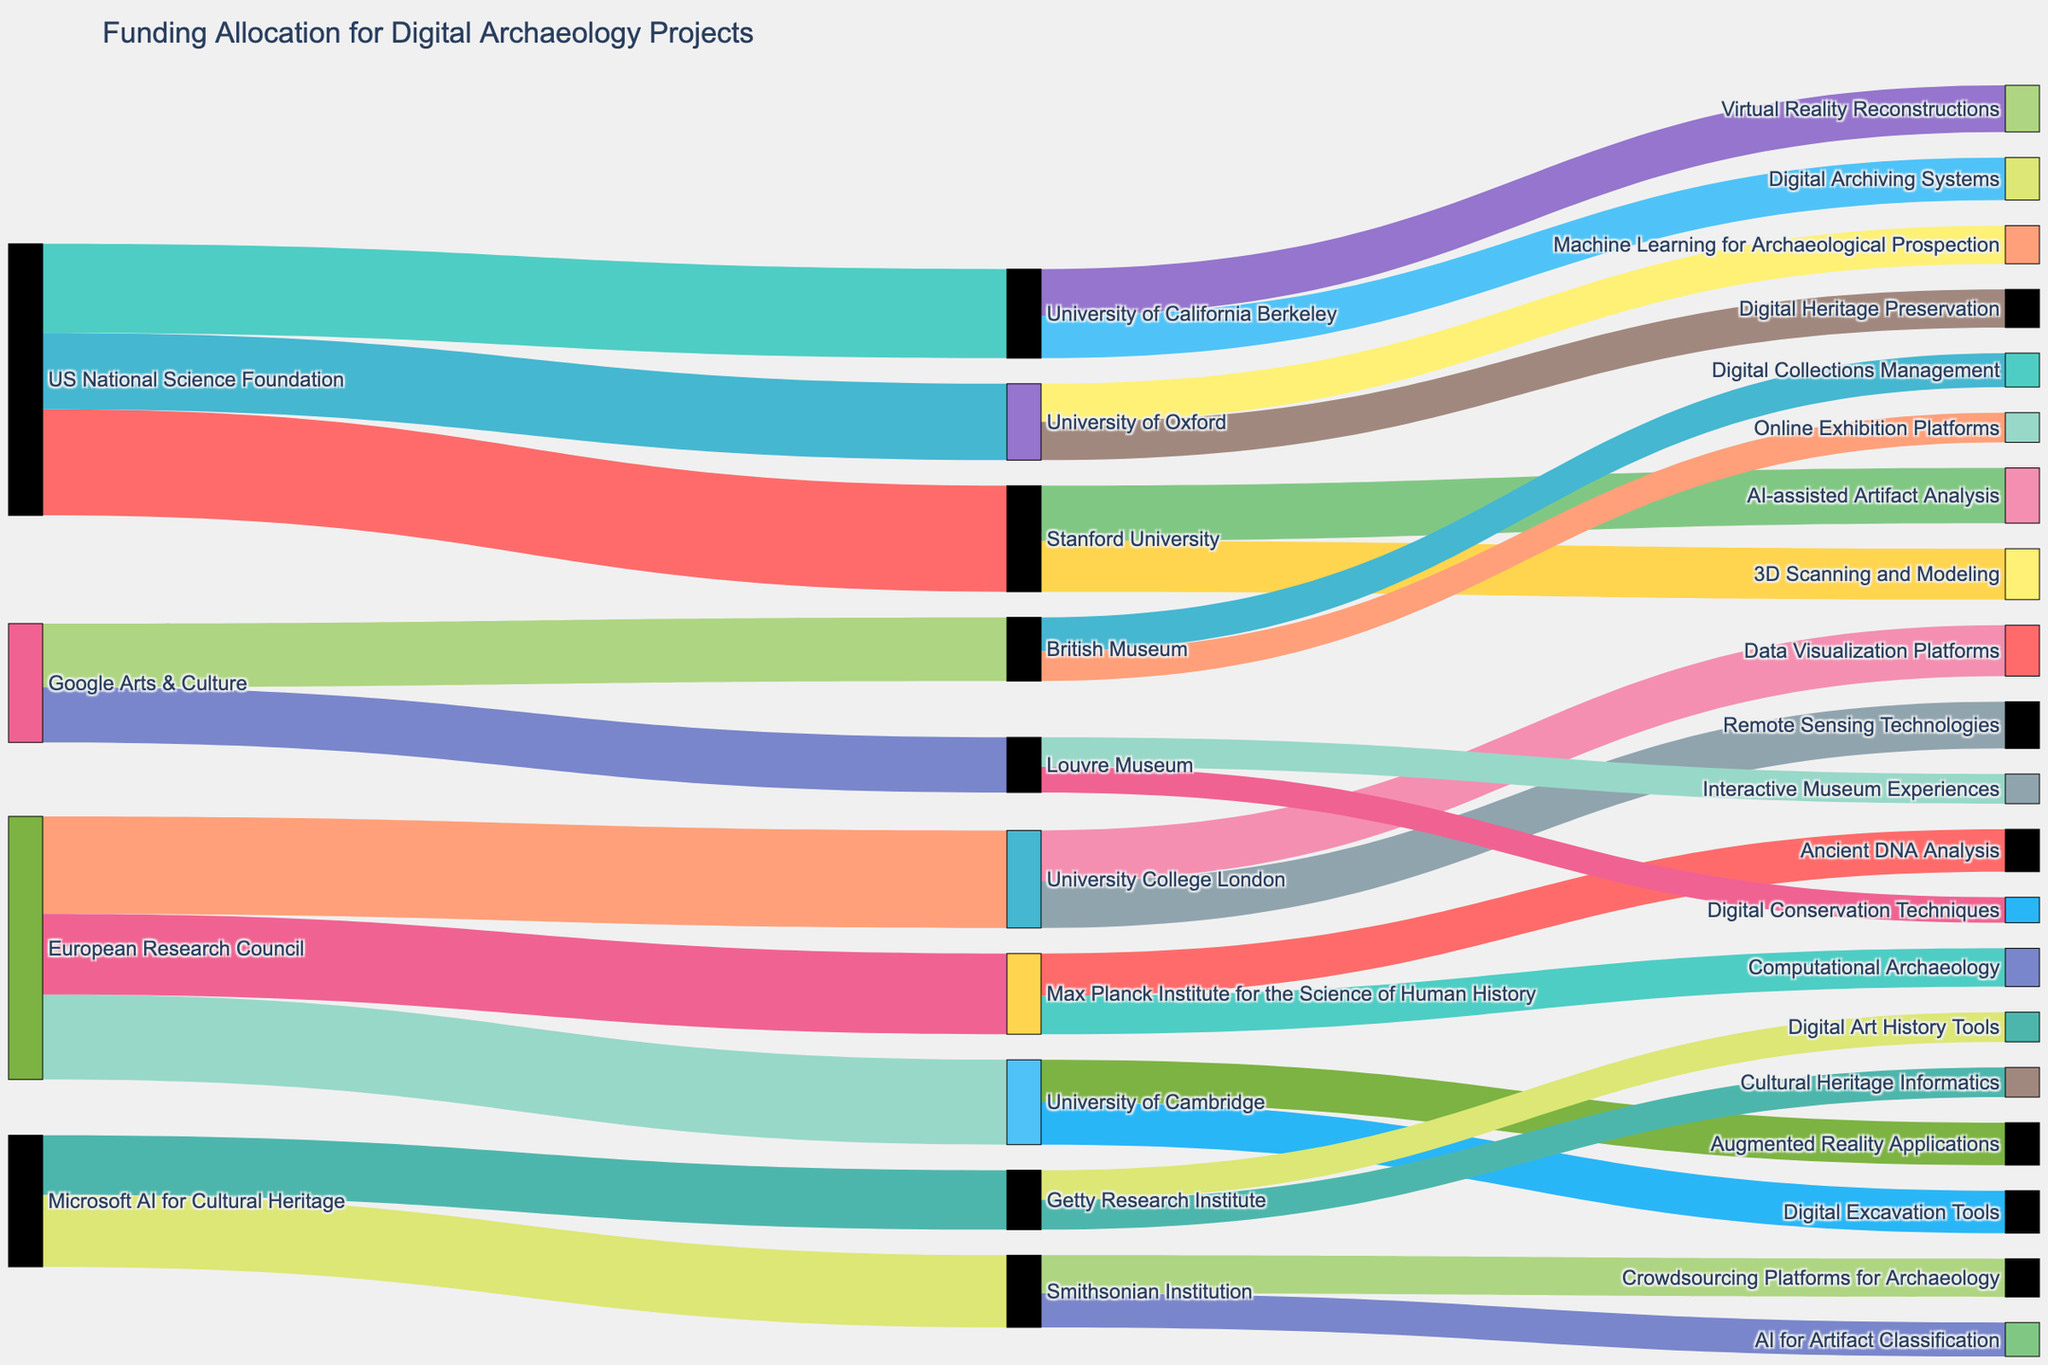What is the title of the Sankey Diagram? The title is typically found at the top of the diagram and indicates the main subject. By looking at the top of the figure, we can see the heading.
Answer: Funding Allocation for Digital Archaeology Projects How many sources are funding digital archaeology projects? To determine how many organizations are providing funds, count the distinct entities on the left side of the diagram that have outgoing flows.
Answer: 4 Which institution received the highest funding from a single source, and how much did they get? By examining the thickness of the links from each funding source to the institutions and reading the labels, we identify the maximum value.
Answer: Stanford University, $2,500,000 How much total funding did the US National Science Foundation allocate? Add the values associated with all the links originating from the US National Science Foundation to get the total allocation. There are three funding paths: Stanford University ($2,500,000), University of California Berkeley ($2,100,000), and University of Oxford ($1,800,000).
Answer: $6,400,000 Which project received the least funding, and from which institution? Look at the thickness and labels of the links connecting institutions to their respective projects, and identify the smallest value.
Answer: Digital Conservation Techniques, Louvre Museum How does the funding to the University of Cambridge compare to that of the Max Planck Institute for the Science of Human History? Sum the funding values directed to each institution from their sources, then compare these totals. University of Cambridge receives $2,000,000 (all from European Research Council), while Max Planck Institute for the Science of Human History receives $1,900,000 (also from European Research Council).
Answer: University of Cambridge receives more What percentage of Google Arts & Culture funding goes to British Museum? Calculate the proportion of funding Google Arts & Culture gives to British Museum vis-a-vis the total from Google Arts & Culture. British Museum ($1,500,000) and Louvre Museum ($1,300,000) sum to $2,800,000.
Answer: Approximately 53.6% What is the combined funding for AI-related projects across all institutions? Identify and sum the values of all projects related to AI, such as AI-assisted Artifact Analysis ($1,300,000), AI for Artifact Classification ($800,000), and others as identified from project names.
Answer: $2,100,000 (Stanford and Smithsonian) Which country hosts the most institutions receiving funding, based on the diagram? Count the target institutions grouped by country: US (Stanford, UC Berkeley, Smithsonian, Getty), UK (Oxford, UCL, Cambridge, British Museum), Germany (Max Planck), France (Louvre). Compare counts.
Answer: United Kingdom By what percentage is the funding to the Smithsonian Institution from Microsoft AI for Cultural Heritage larger than the funding to Getty Research Institute? Determine the difference in funding amounts, divide by the amount received by the Getty Research Institute, multiply by 100 to get the percentage. Funding: Smithsonian ($1,700,000), Getty ($1,400,000), difference ($300,000). Calculation: ($300,000 / $1,400,000) * 100.
Answer: Approximately 21.4% 